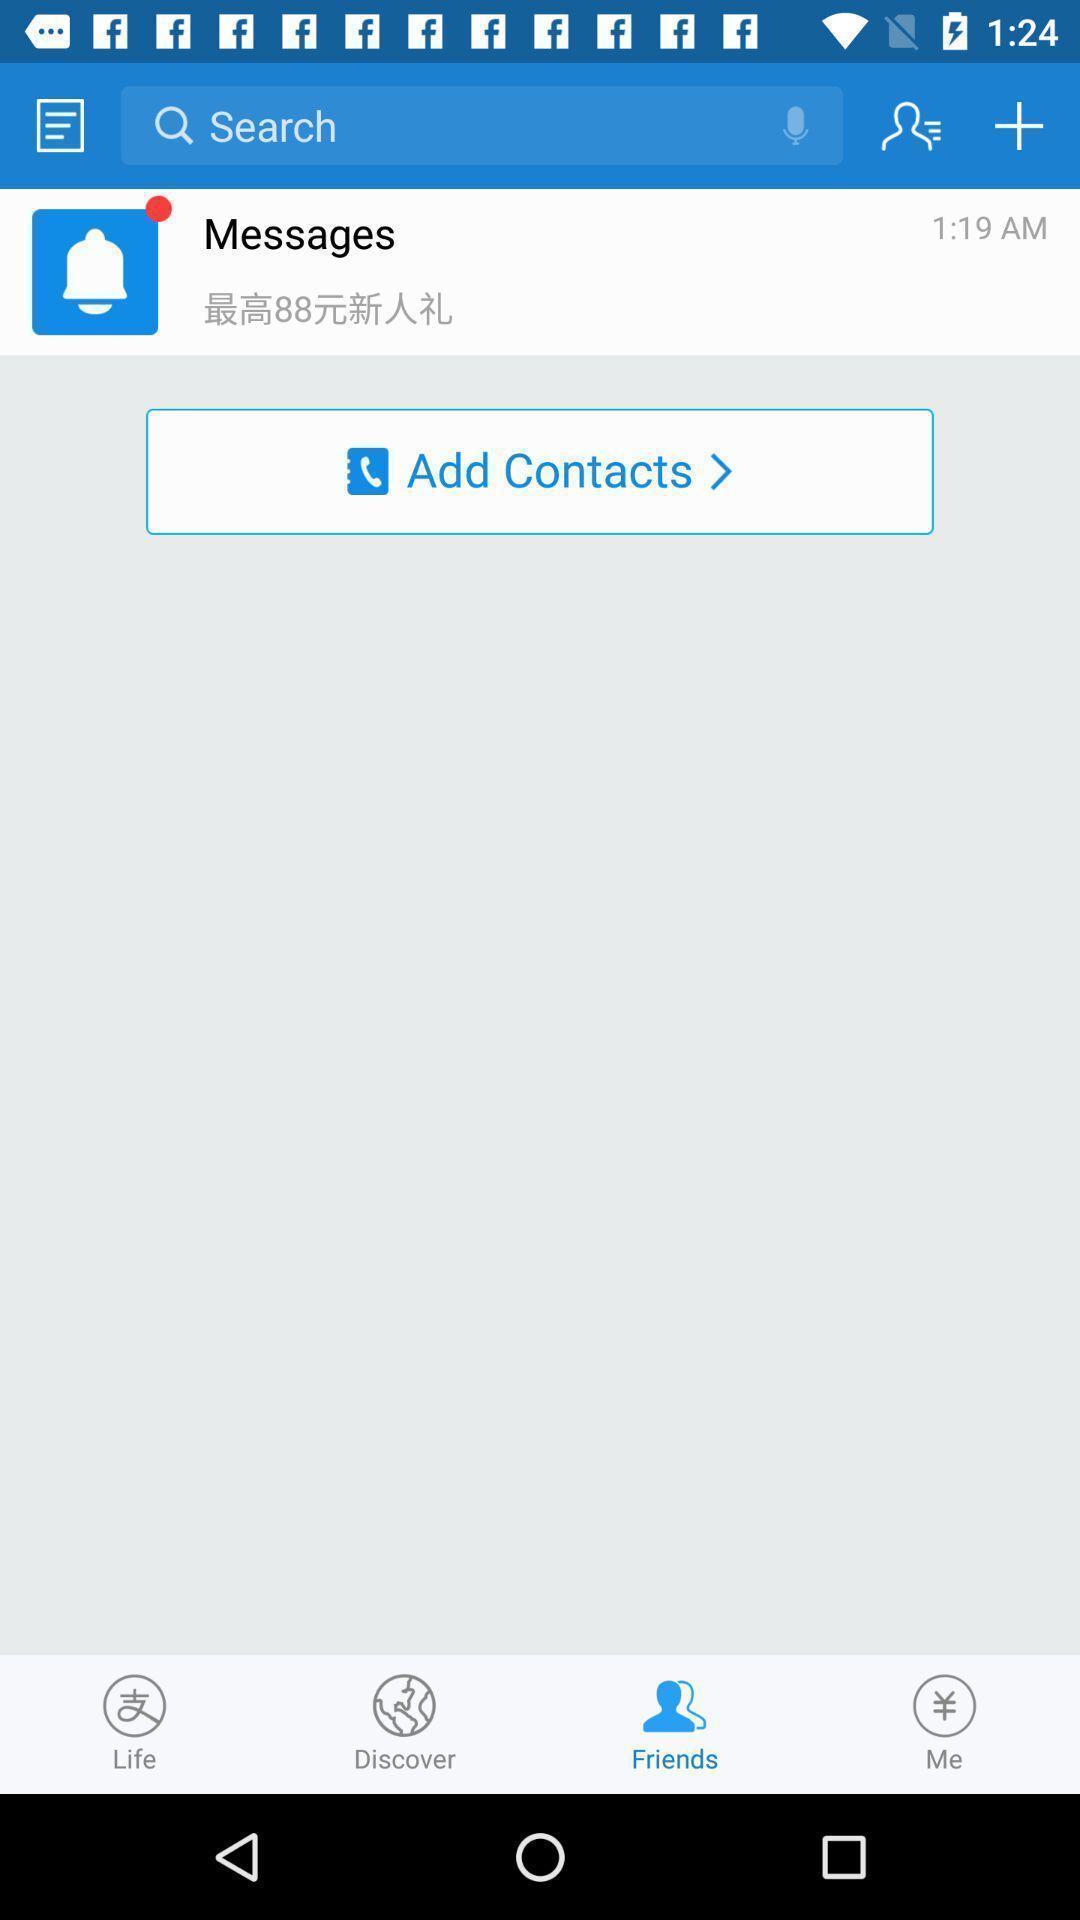Provide a detailed account of this screenshot. Screen displaying the inbox page. 